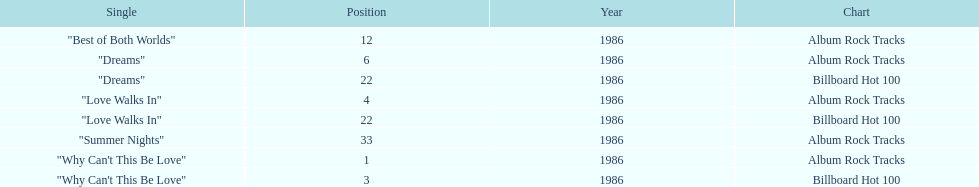Which singles each appear at position 22? Dreams, Love Walks In. 